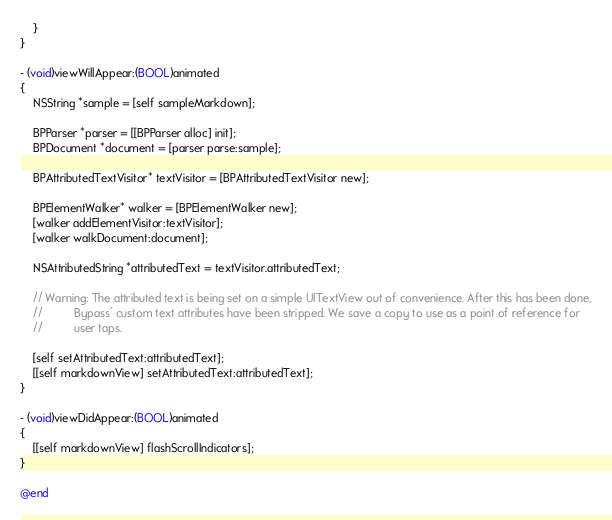Convert code to text. <code><loc_0><loc_0><loc_500><loc_500><_ObjectiveC_>    }
}

- (void)viewWillAppear:(BOOL)animated
{
    NSString *sample = [self sampleMarkdown];
    
    BPParser *parser = [[BPParser alloc] init];
    BPDocument *document = [parser parse:sample];
    
    BPAttributedTextVisitor* textVisitor = [BPAttributedTextVisitor new];

    BPElementWalker* walker = [BPElementWalker new];
    [walker addElementVisitor:textVisitor];
    [walker walkDocument:document];
    
    NSAttributedString *attributedText = textVisitor.attributedText;
    
    // Warning: The attributed text is being set on a simple UITextView out of convenience. After this has been done,
    //          Bypass' custom text attributes have been stripped. We save a copy to use as a point of reference for
    //          user taps.
    
    [self setAttributedText:attributedText];
    [[self markdownView] setAttributedText:attributedText];
}

- (void)viewDidAppear:(BOOL)animated
{
    [[self markdownView] flashScrollIndicators];
}

@end
</code> 